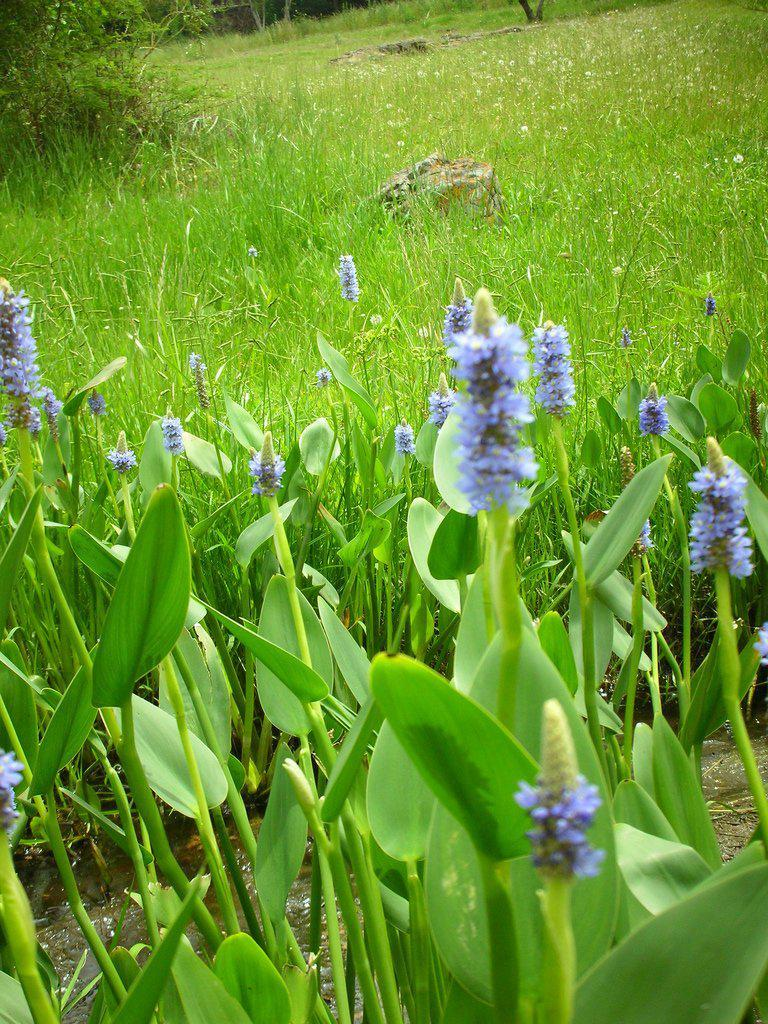What type of plants can be seen in the image? There are plants with flowers in the image. What other natural elements are present in the image? There are trees and grass in the image. Can you describe any inanimate objects in the image? There is a stone in the image. What is the rate at which the shoe is moving in the image? There is no shoe present in the image, so it is not possible to determine its rate of movement. 